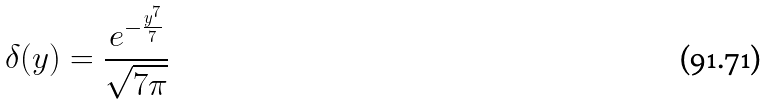Convert formula to latex. <formula><loc_0><loc_0><loc_500><loc_500>\delta ( y ) = \frac { e ^ { - \frac { y ^ { 7 } } { 7 } } } { \sqrt { 7 \pi } }</formula> 